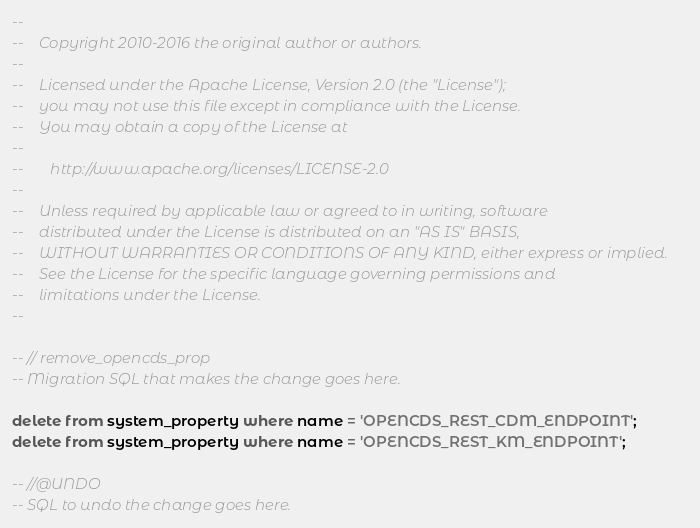Convert code to text. <code><loc_0><loc_0><loc_500><loc_500><_SQL_>--
--    Copyright 2010-2016 the original author or authors.
--
--    Licensed under the Apache License, Version 2.0 (the "License");
--    you may not use this file except in compliance with the License.
--    You may obtain a copy of the License at
--
--       http://www.apache.org/licenses/LICENSE-2.0
--
--    Unless required by applicable law or agreed to in writing, software
--    distributed under the License is distributed on an "AS IS" BASIS,
--    WITHOUT WARRANTIES OR CONDITIONS OF ANY KIND, either express or implied.
--    See the License for the specific language governing permissions and
--    limitations under the License.
--

-- // remove_opencds_prop
-- Migration SQL that makes the change goes here.

delete from system_property where name = 'OPENCDS_REST_CDM_ENDPOINT';
delete from system_property where name = 'OPENCDS_REST_KM_ENDPOINT';

-- //@UNDO
-- SQL to undo the change goes here.


</code> 